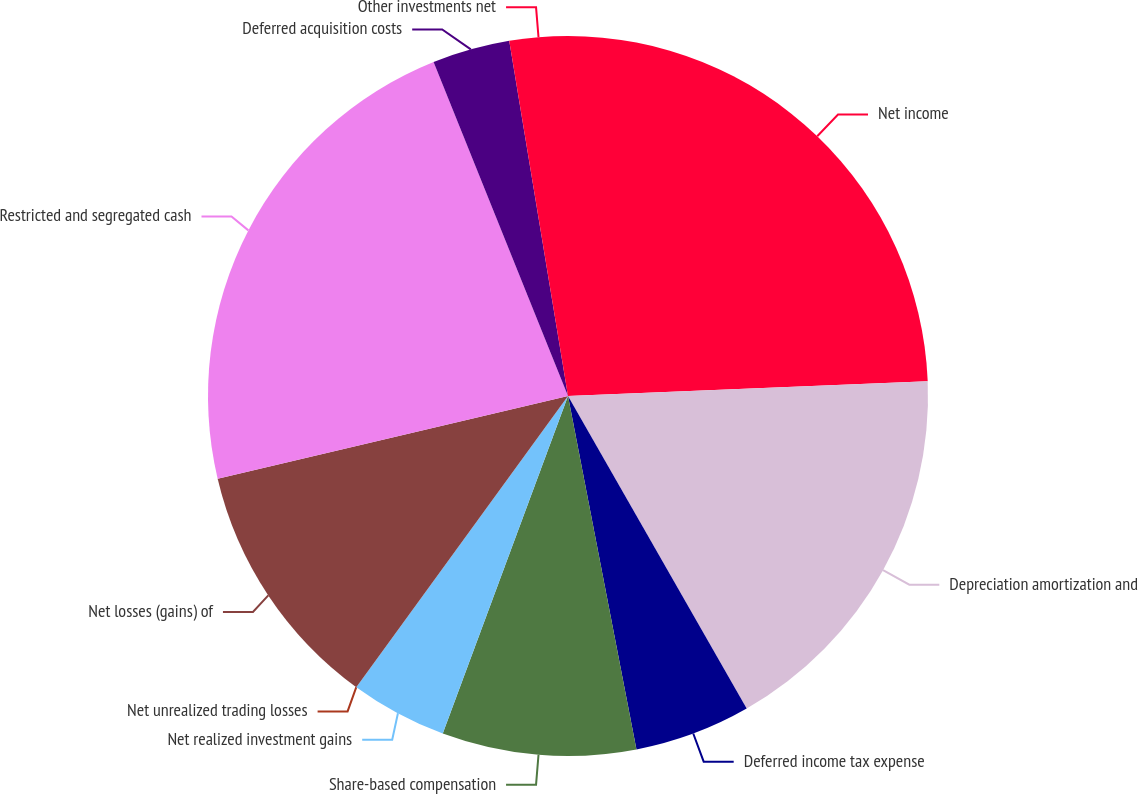Convert chart to OTSL. <chart><loc_0><loc_0><loc_500><loc_500><pie_chart><fcel>Net income<fcel>Depreciation amortization and<fcel>Deferred income tax expense<fcel>Share-based compensation<fcel>Net realized investment gains<fcel>Net unrealized trading losses<fcel>Net losses (gains) of<fcel>Restricted and segregated cash<fcel>Deferred acquisition costs<fcel>Other investments net<nl><fcel>24.34%<fcel>17.39%<fcel>5.22%<fcel>8.7%<fcel>4.35%<fcel>0.0%<fcel>11.3%<fcel>22.6%<fcel>3.48%<fcel>2.61%<nl></chart> 